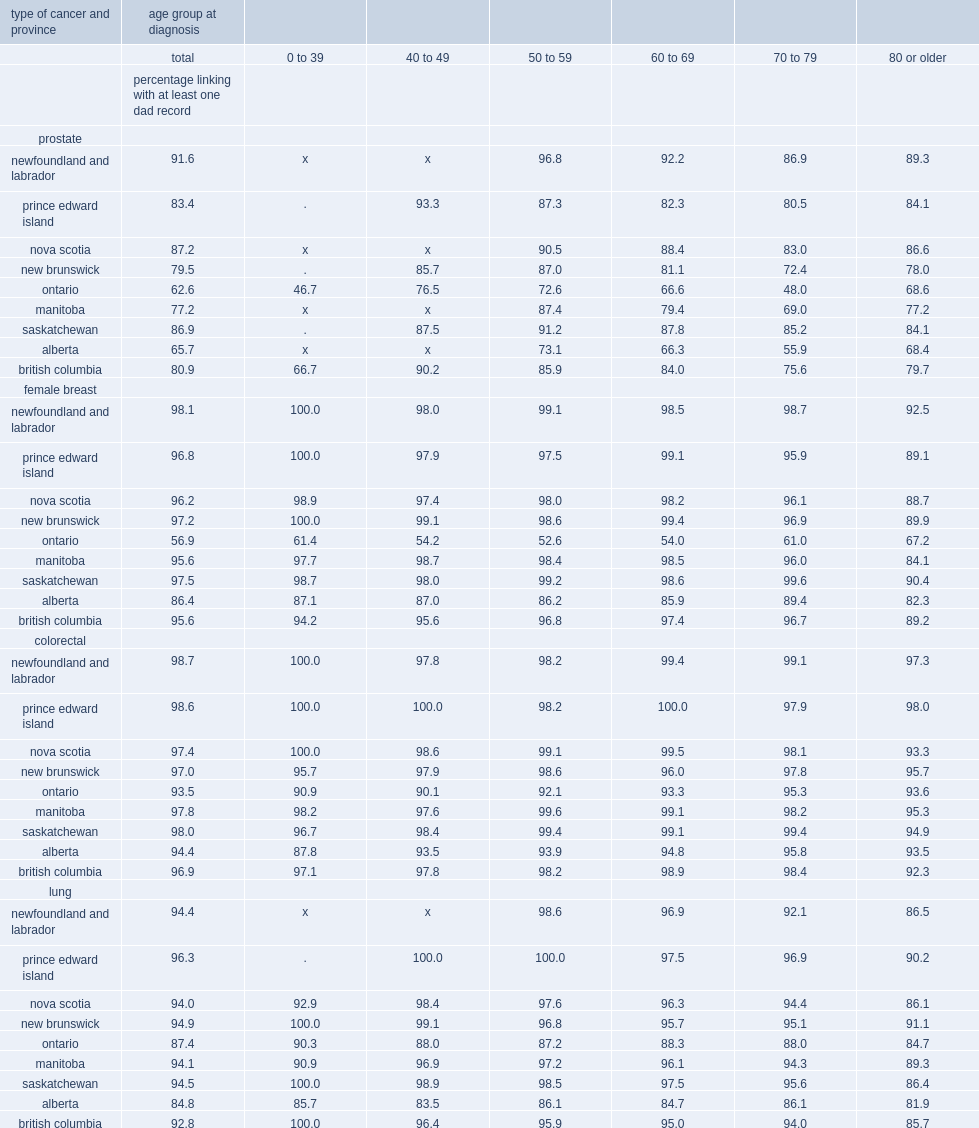For female breast cancer,which province's linkage rates tended to higher in the 80 or older age range? Ontario. 